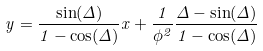Convert formula to latex. <formula><loc_0><loc_0><loc_500><loc_500>y = \frac { \sin ( \Delta ) } { 1 - \cos ( \Delta ) } x + \frac { 1 } { \phi ^ { 2 } } \frac { \Delta - \sin ( \Delta ) } { 1 - \cos ( \Delta ) }</formula> 